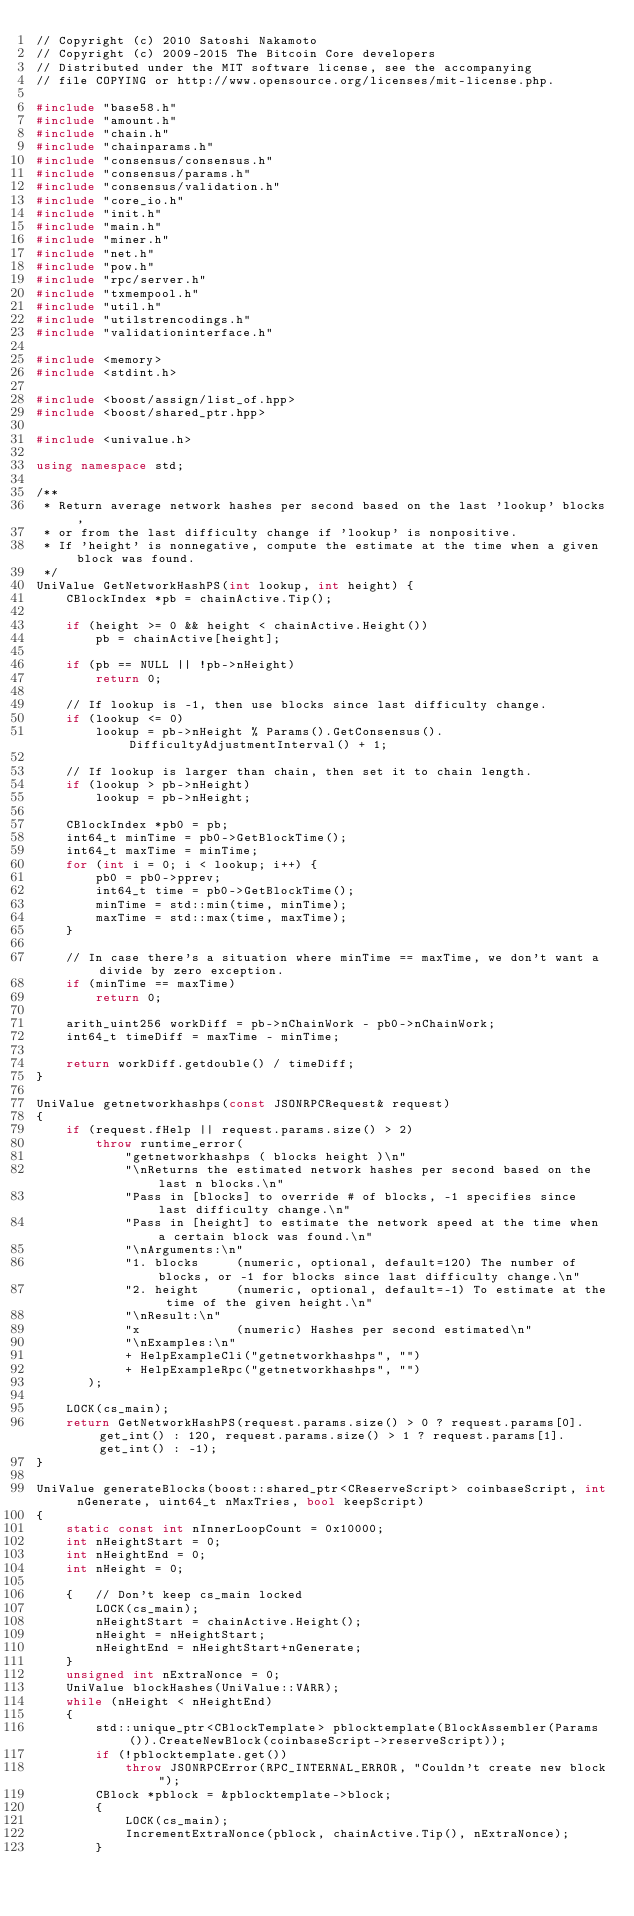Convert code to text. <code><loc_0><loc_0><loc_500><loc_500><_C++_>// Copyright (c) 2010 Satoshi Nakamoto
// Copyright (c) 2009-2015 The Bitcoin Core developers
// Distributed under the MIT software license, see the accompanying
// file COPYING or http://www.opensource.org/licenses/mit-license.php.

#include "base58.h"
#include "amount.h"
#include "chain.h"
#include "chainparams.h"
#include "consensus/consensus.h"
#include "consensus/params.h"
#include "consensus/validation.h"
#include "core_io.h"
#include "init.h"
#include "main.h"
#include "miner.h"
#include "net.h"
#include "pow.h"
#include "rpc/server.h"
#include "txmempool.h"
#include "util.h"
#include "utilstrencodings.h"
#include "validationinterface.h"

#include <memory>
#include <stdint.h>

#include <boost/assign/list_of.hpp>
#include <boost/shared_ptr.hpp>

#include <univalue.h>

using namespace std;

/**
 * Return average network hashes per second based on the last 'lookup' blocks,
 * or from the last difficulty change if 'lookup' is nonpositive.
 * If 'height' is nonnegative, compute the estimate at the time when a given block was found.
 */
UniValue GetNetworkHashPS(int lookup, int height) {
    CBlockIndex *pb = chainActive.Tip();

    if (height >= 0 && height < chainActive.Height())
        pb = chainActive[height];

    if (pb == NULL || !pb->nHeight)
        return 0;

    // If lookup is -1, then use blocks since last difficulty change.
    if (lookup <= 0)
        lookup = pb->nHeight % Params().GetConsensus().DifficultyAdjustmentInterval() + 1;

    // If lookup is larger than chain, then set it to chain length.
    if (lookup > pb->nHeight)
        lookup = pb->nHeight;

    CBlockIndex *pb0 = pb;
    int64_t minTime = pb0->GetBlockTime();
    int64_t maxTime = minTime;
    for (int i = 0; i < lookup; i++) {
        pb0 = pb0->pprev;
        int64_t time = pb0->GetBlockTime();
        minTime = std::min(time, minTime);
        maxTime = std::max(time, maxTime);
    }

    // In case there's a situation where minTime == maxTime, we don't want a divide by zero exception.
    if (minTime == maxTime)
        return 0;

    arith_uint256 workDiff = pb->nChainWork - pb0->nChainWork;
    int64_t timeDiff = maxTime - minTime;

    return workDiff.getdouble() / timeDiff;
}

UniValue getnetworkhashps(const JSONRPCRequest& request)
{
    if (request.fHelp || request.params.size() > 2)
        throw runtime_error(
            "getnetworkhashps ( blocks height )\n"
            "\nReturns the estimated network hashes per second based on the last n blocks.\n"
            "Pass in [blocks] to override # of blocks, -1 specifies since last difficulty change.\n"
            "Pass in [height] to estimate the network speed at the time when a certain block was found.\n"
            "\nArguments:\n"
            "1. blocks     (numeric, optional, default=120) The number of blocks, or -1 for blocks since last difficulty change.\n"
            "2. height     (numeric, optional, default=-1) To estimate at the time of the given height.\n"
            "\nResult:\n"
            "x             (numeric) Hashes per second estimated\n"
            "\nExamples:\n"
            + HelpExampleCli("getnetworkhashps", "")
            + HelpExampleRpc("getnetworkhashps", "")
       );

    LOCK(cs_main);
    return GetNetworkHashPS(request.params.size() > 0 ? request.params[0].get_int() : 120, request.params.size() > 1 ? request.params[1].get_int() : -1);
}

UniValue generateBlocks(boost::shared_ptr<CReserveScript> coinbaseScript, int nGenerate, uint64_t nMaxTries, bool keepScript)
{
    static const int nInnerLoopCount = 0x10000;
    int nHeightStart = 0;
    int nHeightEnd = 0;
    int nHeight = 0;

    {   // Don't keep cs_main locked
        LOCK(cs_main);
        nHeightStart = chainActive.Height();
        nHeight = nHeightStart;
        nHeightEnd = nHeightStart+nGenerate;
    }
    unsigned int nExtraNonce = 0;
    UniValue blockHashes(UniValue::VARR);
    while (nHeight < nHeightEnd)
    {
        std::unique_ptr<CBlockTemplate> pblocktemplate(BlockAssembler(Params()).CreateNewBlock(coinbaseScript->reserveScript));
        if (!pblocktemplate.get())
            throw JSONRPCError(RPC_INTERNAL_ERROR, "Couldn't create new block");
        CBlock *pblock = &pblocktemplate->block;
        {
            LOCK(cs_main);
            IncrementExtraNonce(pblock, chainActive.Tip(), nExtraNonce);
        }</code> 